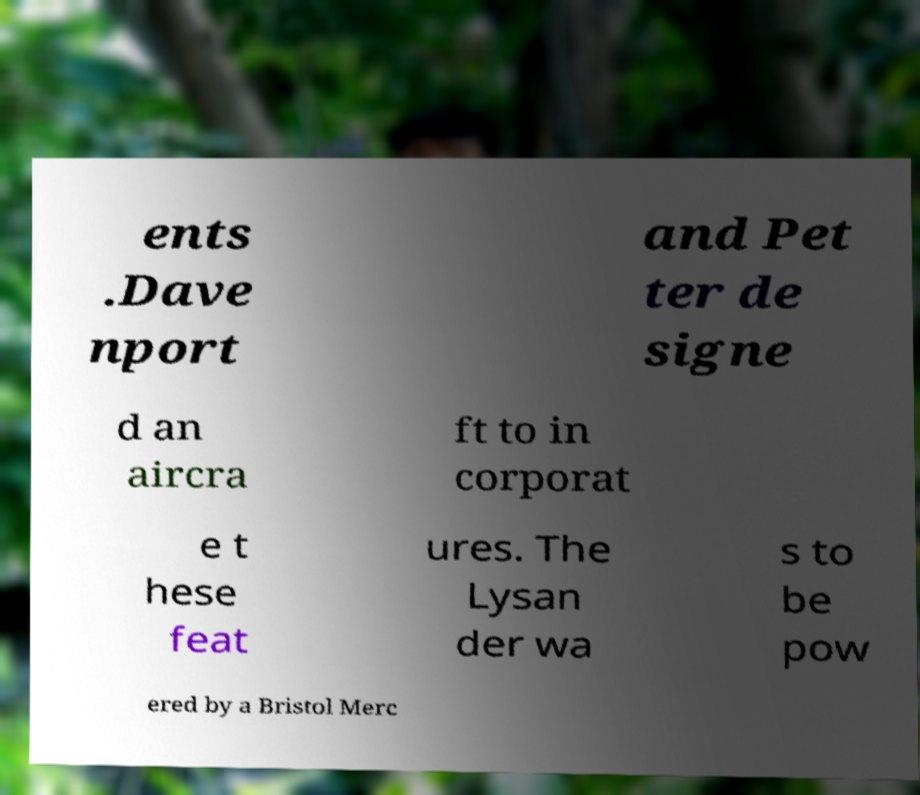For documentation purposes, I need the text within this image transcribed. Could you provide that? ents .Dave nport and Pet ter de signe d an aircra ft to in corporat e t hese feat ures. The Lysan der wa s to be pow ered by a Bristol Merc 